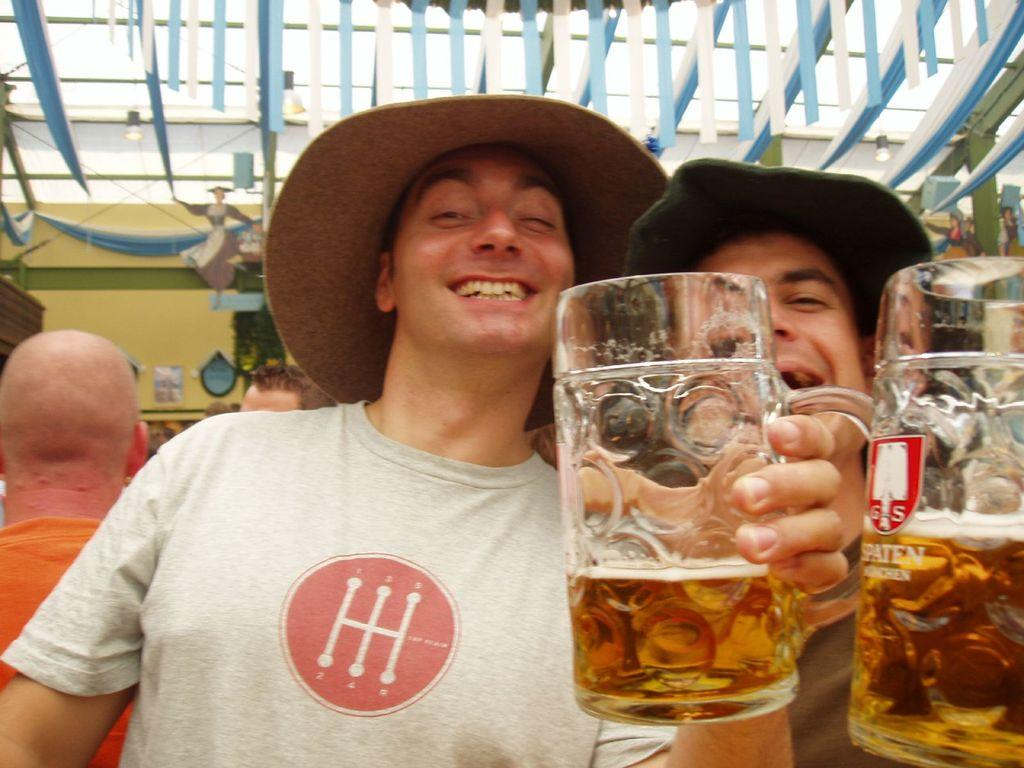How many people are in the image? There are two persons in the image. Where are the persons located in the image? Both persons are in the middle of the image. What is one person wearing in the image? One person is wearing a cap. What is one person holding in the image? One person is holding a glass with their hand. What type of window can be seen in the image? There is no window present in the image; it features two persons, one wearing a cap and the other holding a glass. How many angles can be seen in the image? There are no angles visible in the image; it is a photograph of two people. 